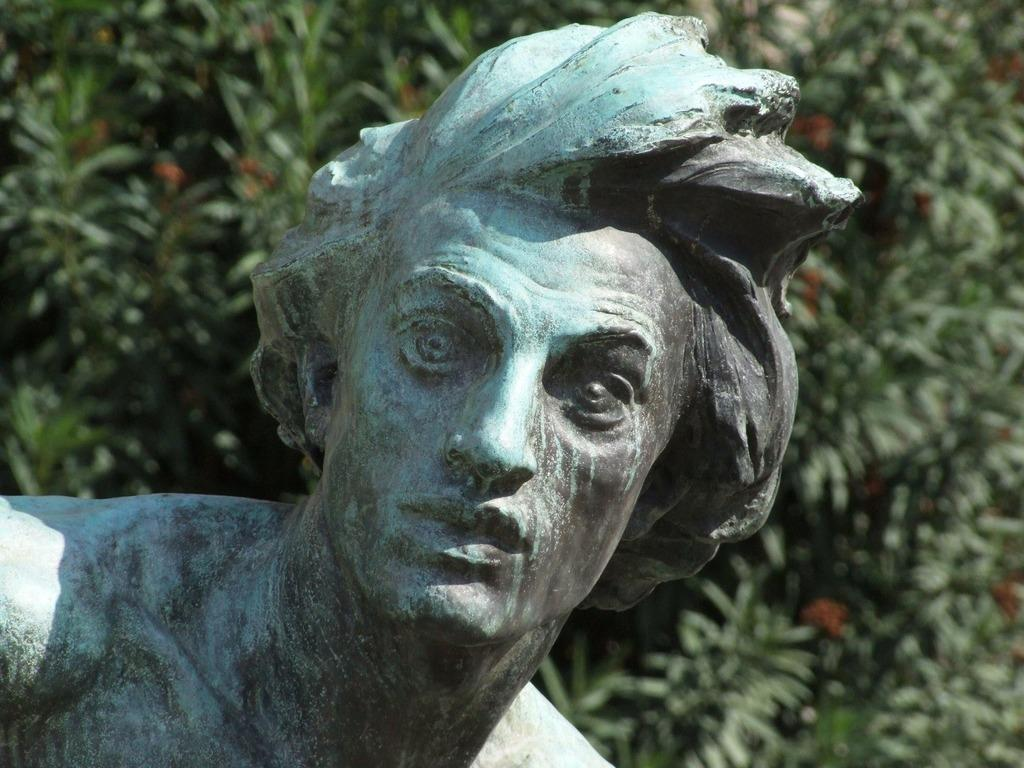What is the main subject of the image? There is a statue of a man in the image. What can be seen in the background of the image? There are trees visible in the image. What type of bomb is being detonated in the image? There is no bomb present in the image; it features a statue of a man and trees in the background. How does the statue express disgust in the image? The statue does not express any emotions, including disgust, as it is an inanimate object. 